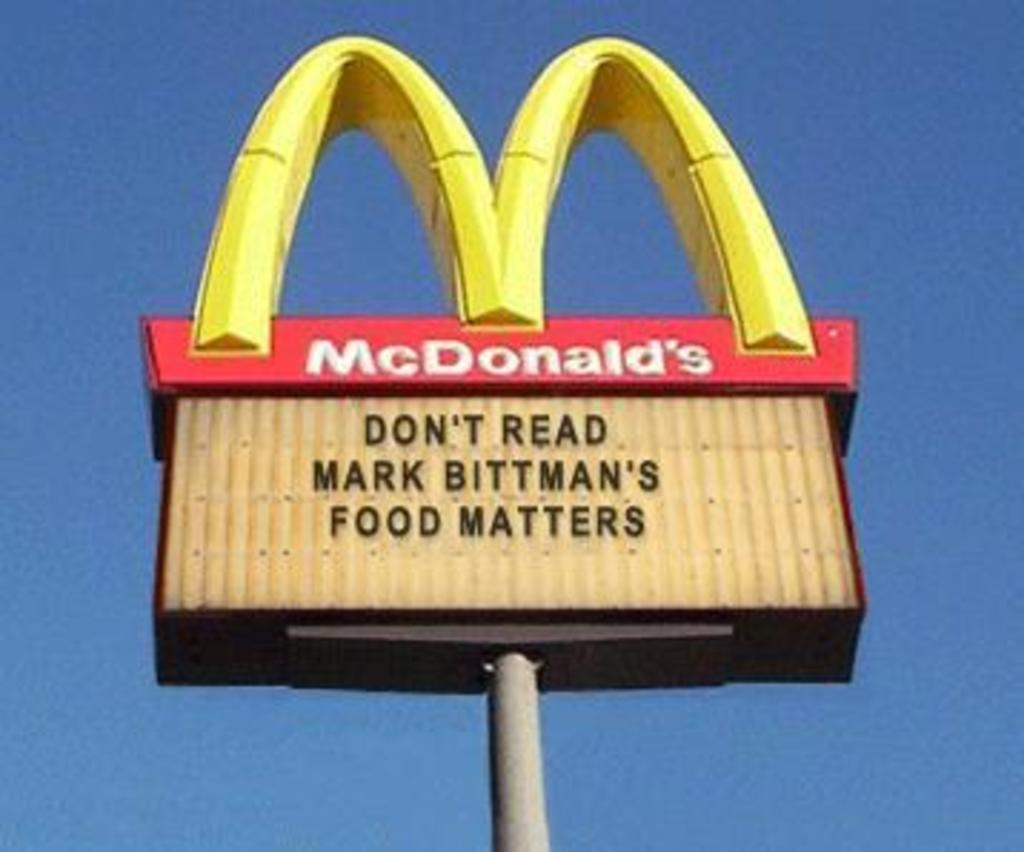<image>
Render a clear and concise summary of the photo. A McDonald's sign with a shout out to Mark Bittman 